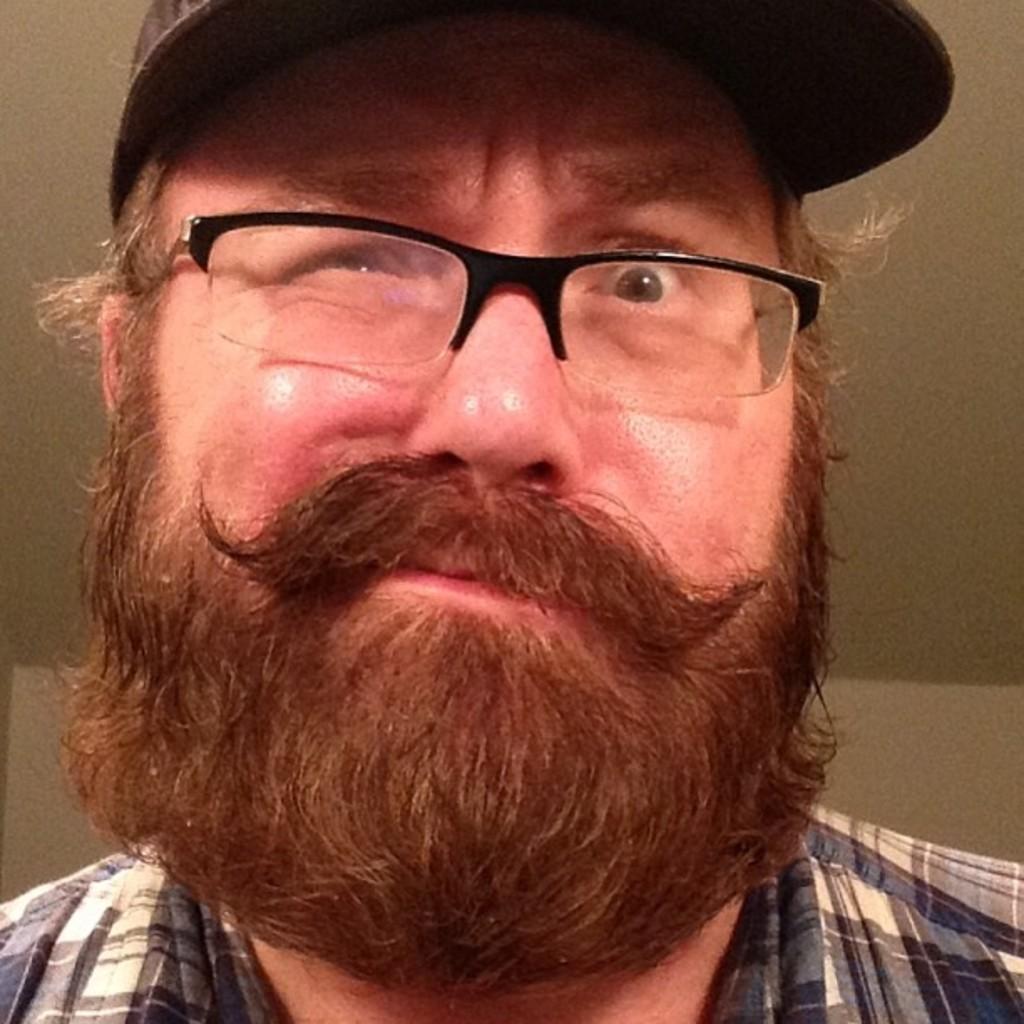How would you summarize this image in a sentence or two? In this image we can see a man wearing the glasses and also the cap. In the background we can see the ceiling and also the wall. 